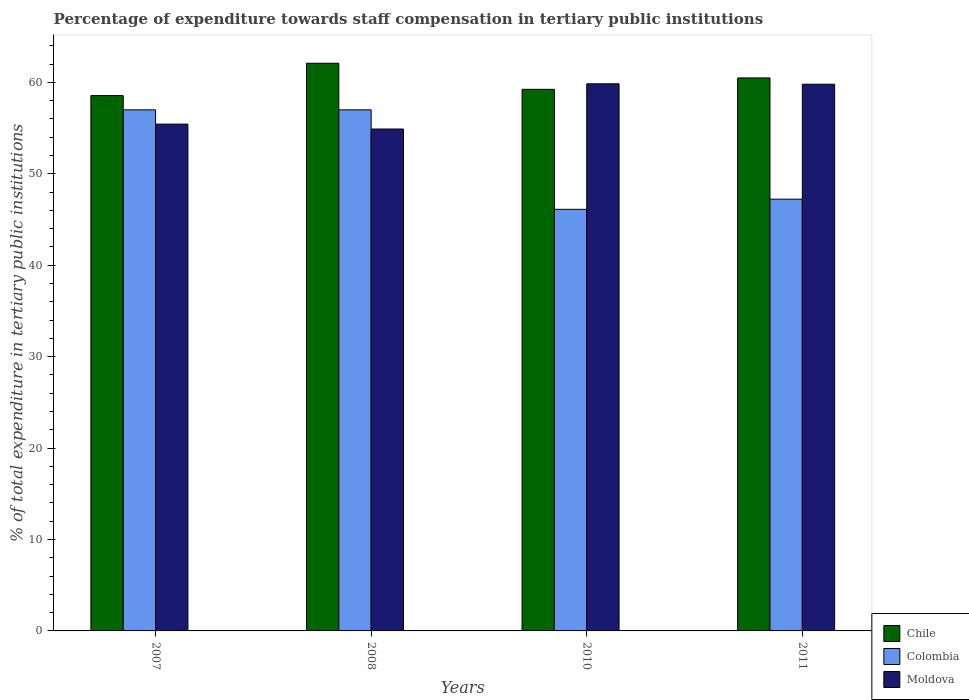Are the number of bars per tick equal to the number of legend labels?
Ensure brevity in your answer.  Yes. Are the number of bars on each tick of the X-axis equal?
Provide a succinct answer. Yes. In how many cases, is the number of bars for a given year not equal to the number of legend labels?
Your answer should be compact. 0. What is the percentage of expenditure towards staff compensation in Colombia in 2007?
Your answer should be compact. 57. Across all years, what is the maximum percentage of expenditure towards staff compensation in Moldova?
Offer a terse response. 59.85. Across all years, what is the minimum percentage of expenditure towards staff compensation in Colombia?
Your answer should be very brief. 46.12. In which year was the percentage of expenditure towards staff compensation in Moldova maximum?
Provide a succinct answer. 2010. What is the total percentage of expenditure towards staff compensation in Moldova in the graph?
Offer a very short reply. 229.98. What is the difference between the percentage of expenditure towards staff compensation in Moldova in 2007 and that in 2008?
Provide a short and direct response. 0.54. What is the difference between the percentage of expenditure towards staff compensation in Chile in 2011 and the percentage of expenditure towards staff compensation in Colombia in 2007?
Your response must be concise. 3.49. What is the average percentage of expenditure towards staff compensation in Chile per year?
Ensure brevity in your answer.  60.09. In the year 2010, what is the difference between the percentage of expenditure towards staff compensation in Colombia and percentage of expenditure towards staff compensation in Moldova?
Your answer should be very brief. -13.73. In how many years, is the percentage of expenditure towards staff compensation in Colombia greater than 34 %?
Your response must be concise. 4. What is the ratio of the percentage of expenditure towards staff compensation in Moldova in 2007 to that in 2008?
Ensure brevity in your answer.  1.01. Is the difference between the percentage of expenditure towards staff compensation in Colombia in 2008 and 2010 greater than the difference between the percentage of expenditure towards staff compensation in Moldova in 2008 and 2010?
Your response must be concise. Yes. What is the difference between the highest and the second highest percentage of expenditure towards staff compensation in Chile?
Give a very brief answer. 1.61. What is the difference between the highest and the lowest percentage of expenditure towards staff compensation in Moldova?
Offer a terse response. 4.95. What does the 2nd bar from the right in 2010 represents?
Your answer should be compact. Colombia. Are all the bars in the graph horizontal?
Your response must be concise. No. How many years are there in the graph?
Make the answer very short. 4. Where does the legend appear in the graph?
Provide a short and direct response. Bottom right. How many legend labels are there?
Give a very brief answer. 3. How are the legend labels stacked?
Offer a terse response. Vertical. What is the title of the graph?
Provide a succinct answer. Percentage of expenditure towards staff compensation in tertiary public institutions. Does "Bosnia and Herzegovina" appear as one of the legend labels in the graph?
Provide a succinct answer. No. What is the label or title of the Y-axis?
Offer a terse response. % of total expenditure in tertiary public institutions. What is the % of total expenditure in tertiary public institutions in Chile in 2007?
Provide a short and direct response. 58.56. What is the % of total expenditure in tertiary public institutions in Colombia in 2007?
Ensure brevity in your answer.  57. What is the % of total expenditure in tertiary public institutions of Moldova in 2007?
Keep it short and to the point. 55.44. What is the % of total expenditure in tertiary public institutions in Chile in 2008?
Make the answer very short. 62.09. What is the % of total expenditure in tertiary public institutions in Colombia in 2008?
Your answer should be very brief. 57. What is the % of total expenditure in tertiary public institutions of Moldova in 2008?
Provide a succinct answer. 54.9. What is the % of total expenditure in tertiary public institutions in Chile in 2010?
Make the answer very short. 59.24. What is the % of total expenditure in tertiary public institutions in Colombia in 2010?
Provide a short and direct response. 46.12. What is the % of total expenditure in tertiary public institutions of Moldova in 2010?
Your response must be concise. 59.85. What is the % of total expenditure in tertiary public institutions of Chile in 2011?
Provide a short and direct response. 60.49. What is the % of total expenditure in tertiary public institutions of Colombia in 2011?
Your answer should be compact. 47.23. What is the % of total expenditure in tertiary public institutions in Moldova in 2011?
Keep it short and to the point. 59.8. Across all years, what is the maximum % of total expenditure in tertiary public institutions of Chile?
Your answer should be compact. 62.09. Across all years, what is the maximum % of total expenditure in tertiary public institutions in Colombia?
Offer a very short reply. 57. Across all years, what is the maximum % of total expenditure in tertiary public institutions of Moldova?
Ensure brevity in your answer.  59.85. Across all years, what is the minimum % of total expenditure in tertiary public institutions of Chile?
Provide a succinct answer. 58.56. Across all years, what is the minimum % of total expenditure in tertiary public institutions in Colombia?
Your response must be concise. 46.12. Across all years, what is the minimum % of total expenditure in tertiary public institutions in Moldova?
Give a very brief answer. 54.9. What is the total % of total expenditure in tertiary public institutions in Chile in the graph?
Your response must be concise. 240.38. What is the total % of total expenditure in tertiary public institutions of Colombia in the graph?
Your answer should be very brief. 207.34. What is the total % of total expenditure in tertiary public institutions in Moldova in the graph?
Provide a short and direct response. 229.98. What is the difference between the % of total expenditure in tertiary public institutions of Chile in 2007 and that in 2008?
Make the answer very short. -3.54. What is the difference between the % of total expenditure in tertiary public institutions in Moldova in 2007 and that in 2008?
Your answer should be very brief. 0.54. What is the difference between the % of total expenditure in tertiary public institutions in Chile in 2007 and that in 2010?
Keep it short and to the point. -0.69. What is the difference between the % of total expenditure in tertiary public institutions in Colombia in 2007 and that in 2010?
Your response must be concise. 10.88. What is the difference between the % of total expenditure in tertiary public institutions of Moldova in 2007 and that in 2010?
Keep it short and to the point. -4.41. What is the difference between the % of total expenditure in tertiary public institutions of Chile in 2007 and that in 2011?
Provide a succinct answer. -1.93. What is the difference between the % of total expenditure in tertiary public institutions in Colombia in 2007 and that in 2011?
Make the answer very short. 9.77. What is the difference between the % of total expenditure in tertiary public institutions of Moldova in 2007 and that in 2011?
Provide a succinct answer. -4.36. What is the difference between the % of total expenditure in tertiary public institutions of Chile in 2008 and that in 2010?
Ensure brevity in your answer.  2.85. What is the difference between the % of total expenditure in tertiary public institutions of Colombia in 2008 and that in 2010?
Your response must be concise. 10.88. What is the difference between the % of total expenditure in tertiary public institutions in Moldova in 2008 and that in 2010?
Offer a terse response. -4.95. What is the difference between the % of total expenditure in tertiary public institutions of Chile in 2008 and that in 2011?
Make the answer very short. 1.6. What is the difference between the % of total expenditure in tertiary public institutions in Colombia in 2008 and that in 2011?
Keep it short and to the point. 9.77. What is the difference between the % of total expenditure in tertiary public institutions of Moldova in 2008 and that in 2011?
Offer a very short reply. -4.9. What is the difference between the % of total expenditure in tertiary public institutions of Chile in 2010 and that in 2011?
Provide a succinct answer. -1.25. What is the difference between the % of total expenditure in tertiary public institutions in Colombia in 2010 and that in 2011?
Ensure brevity in your answer.  -1.11. What is the difference between the % of total expenditure in tertiary public institutions of Moldova in 2010 and that in 2011?
Your answer should be compact. 0.04. What is the difference between the % of total expenditure in tertiary public institutions in Chile in 2007 and the % of total expenditure in tertiary public institutions in Colombia in 2008?
Your answer should be compact. 1.56. What is the difference between the % of total expenditure in tertiary public institutions of Chile in 2007 and the % of total expenditure in tertiary public institutions of Moldova in 2008?
Offer a very short reply. 3.66. What is the difference between the % of total expenditure in tertiary public institutions of Colombia in 2007 and the % of total expenditure in tertiary public institutions of Moldova in 2008?
Make the answer very short. 2.1. What is the difference between the % of total expenditure in tertiary public institutions in Chile in 2007 and the % of total expenditure in tertiary public institutions in Colombia in 2010?
Make the answer very short. 12.44. What is the difference between the % of total expenditure in tertiary public institutions of Chile in 2007 and the % of total expenditure in tertiary public institutions of Moldova in 2010?
Ensure brevity in your answer.  -1.29. What is the difference between the % of total expenditure in tertiary public institutions of Colombia in 2007 and the % of total expenditure in tertiary public institutions of Moldova in 2010?
Provide a short and direct response. -2.85. What is the difference between the % of total expenditure in tertiary public institutions of Chile in 2007 and the % of total expenditure in tertiary public institutions of Colombia in 2011?
Provide a succinct answer. 11.33. What is the difference between the % of total expenditure in tertiary public institutions in Chile in 2007 and the % of total expenditure in tertiary public institutions in Moldova in 2011?
Provide a short and direct response. -1.25. What is the difference between the % of total expenditure in tertiary public institutions of Colombia in 2007 and the % of total expenditure in tertiary public institutions of Moldova in 2011?
Ensure brevity in your answer.  -2.8. What is the difference between the % of total expenditure in tertiary public institutions of Chile in 2008 and the % of total expenditure in tertiary public institutions of Colombia in 2010?
Offer a very short reply. 15.98. What is the difference between the % of total expenditure in tertiary public institutions of Chile in 2008 and the % of total expenditure in tertiary public institutions of Moldova in 2010?
Give a very brief answer. 2.25. What is the difference between the % of total expenditure in tertiary public institutions in Colombia in 2008 and the % of total expenditure in tertiary public institutions in Moldova in 2010?
Your answer should be compact. -2.85. What is the difference between the % of total expenditure in tertiary public institutions of Chile in 2008 and the % of total expenditure in tertiary public institutions of Colombia in 2011?
Provide a succinct answer. 14.87. What is the difference between the % of total expenditure in tertiary public institutions in Chile in 2008 and the % of total expenditure in tertiary public institutions in Moldova in 2011?
Your answer should be compact. 2.29. What is the difference between the % of total expenditure in tertiary public institutions of Colombia in 2008 and the % of total expenditure in tertiary public institutions of Moldova in 2011?
Your answer should be very brief. -2.8. What is the difference between the % of total expenditure in tertiary public institutions of Chile in 2010 and the % of total expenditure in tertiary public institutions of Colombia in 2011?
Your response must be concise. 12.01. What is the difference between the % of total expenditure in tertiary public institutions of Chile in 2010 and the % of total expenditure in tertiary public institutions of Moldova in 2011?
Keep it short and to the point. -0.56. What is the difference between the % of total expenditure in tertiary public institutions in Colombia in 2010 and the % of total expenditure in tertiary public institutions in Moldova in 2011?
Offer a terse response. -13.68. What is the average % of total expenditure in tertiary public institutions in Chile per year?
Offer a very short reply. 60.09. What is the average % of total expenditure in tertiary public institutions in Colombia per year?
Make the answer very short. 51.83. What is the average % of total expenditure in tertiary public institutions of Moldova per year?
Offer a very short reply. 57.5. In the year 2007, what is the difference between the % of total expenditure in tertiary public institutions of Chile and % of total expenditure in tertiary public institutions of Colombia?
Your response must be concise. 1.56. In the year 2007, what is the difference between the % of total expenditure in tertiary public institutions of Chile and % of total expenditure in tertiary public institutions of Moldova?
Offer a very short reply. 3.12. In the year 2007, what is the difference between the % of total expenditure in tertiary public institutions in Colombia and % of total expenditure in tertiary public institutions in Moldova?
Your answer should be very brief. 1.56. In the year 2008, what is the difference between the % of total expenditure in tertiary public institutions of Chile and % of total expenditure in tertiary public institutions of Colombia?
Give a very brief answer. 5.09. In the year 2008, what is the difference between the % of total expenditure in tertiary public institutions in Chile and % of total expenditure in tertiary public institutions in Moldova?
Provide a succinct answer. 7.19. In the year 2008, what is the difference between the % of total expenditure in tertiary public institutions in Colombia and % of total expenditure in tertiary public institutions in Moldova?
Your answer should be very brief. 2.1. In the year 2010, what is the difference between the % of total expenditure in tertiary public institutions of Chile and % of total expenditure in tertiary public institutions of Colombia?
Your response must be concise. 13.12. In the year 2010, what is the difference between the % of total expenditure in tertiary public institutions in Chile and % of total expenditure in tertiary public institutions in Moldova?
Give a very brief answer. -0.61. In the year 2010, what is the difference between the % of total expenditure in tertiary public institutions in Colombia and % of total expenditure in tertiary public institutions in Moldova?
Your answer should be very brief. -13.73. In the year 2011, what is the difference between the % of total expenditure in tertiary public institutions in Chile and % of total expenditure in tertiary public institutions in Colombia?
Make the answer very short. 13.26. In the year 2011, what is the difference between the % of total expenditure in tertiary public institutions in Chile and % of total expenditure in tertiary public institutions in Moldova?
Your response must be concise. 0.69. In the year 2011, what is the difference between the % of total expenditure in tertiary public institutions of Colombia and % of total expenditure in tertiary public institutions of Moldova?
Offer a very short reply. -12.57. What is the ratio of the % of total expenditure in tertiary public institutions of Chile in 2007 to that in 2008?
Your answer should be very brief. 0.94. What is the ratio of the % of total expenditure in tertiary public institutions in Colombia in 2007 to that in 2008?
Make the answer very short. 1. What is the ratio of the % of total expenditure in tertiary public institutions of Moldova in 2007 to that in 2008?
Your response must be concise. 1.01. What is the ratio of the % of total expenditure in tertiary public institutions of Chile in 2007 to that in 2010?
Offer a terse response. 0.99. What is the ratio of the % of total expenditure in tertiary public institutions of Colombia in 2007 to that in 2010?
Provide a short and direct response. 1.24. What is the ratio of the % of total expenditure in tertiary public institutions in Moldova in 2007 to that in 2010?
Provide a short and direct response. 0.93. What is the ratio of the % of total expenditure in tertiary public institutions of Chile in 2007 to that in 2011?
Keep it short and to the point. 0.97. What is the ratio of the % of total expenditure in tertiary public institutions of Colombia in 2007 to that in 2011?
Make the answer very short. 1.21. What is the ratio of the % of total expenditure in tertiary public institutions of Moldova in 2007 to that in 2011?
Ensure brevity in your answer.  0.93. What is the ratio of the % of total expenditure in tertiary public institutions in Chile in 2008 to that in 2010?
Make the answer very short. 1.05. What is the ratio of the % of total expenditure in tertiary public institutions in Colombia in 2008 to that in 2010?
Give a very brief answer. 1.24. What is the ratio of the % of total expenditure in tertiary public institutions in Moldova in 2008 to that in 2010?
Provide a succinct answer. 0.92. What is the ratio of the % of total expenditure in tertiary public institutions in Chile in 2008 to that in 2011?
Your answer should be compact. 1.03. What is the ratio of the % of total expenditure in tertiary public institutions in Colombia in 2008 to that in 2011?
Offer a very short reply. 1.21. What is the ratio of the % of total expenditure in tertiary public institutions of Moldova in 2008 to that in 2011?
Provide a succinct answer. 0.92. What is the ratio of the % of total expenditure in tertiary public institutions of Chile in 2010 to that in 2011?
Provide a succinct answer. 0.98. What is the ratio of the % of total expenditure in tertiary public institutions of Colombia in 2010 to that in 2011?
Give a very brief answer. 0.98. What is the difference between the highest and the second highest % of total expenditure in tertiary public institutions of Chile?
Your response must be concise. 1.6. What is the difference between the highest and the second highest % of total expenditure in tertiary public institutions of Colombia?
Your answer should be very brief. 0. What is the difference between the highest and the second highest % of total expenditure in tertiary public institutions of Moldova?
Provide a short and direct response. 0.04. What is the difference between the highest and the lowest % of total expenditure in tertiary public institutions in Chile?
Ensure brevity in your answer.  3.54. What is the difference between the highest and the lowest % of total expenditure in tertiary public institutions in Colombia?
Ensure brevity in your answer.  10.88. What is the difference between the highest and the lowest % of total expenditure in tertiary public institutions of Moldova?
Your answer should be very brief. 4.95. 